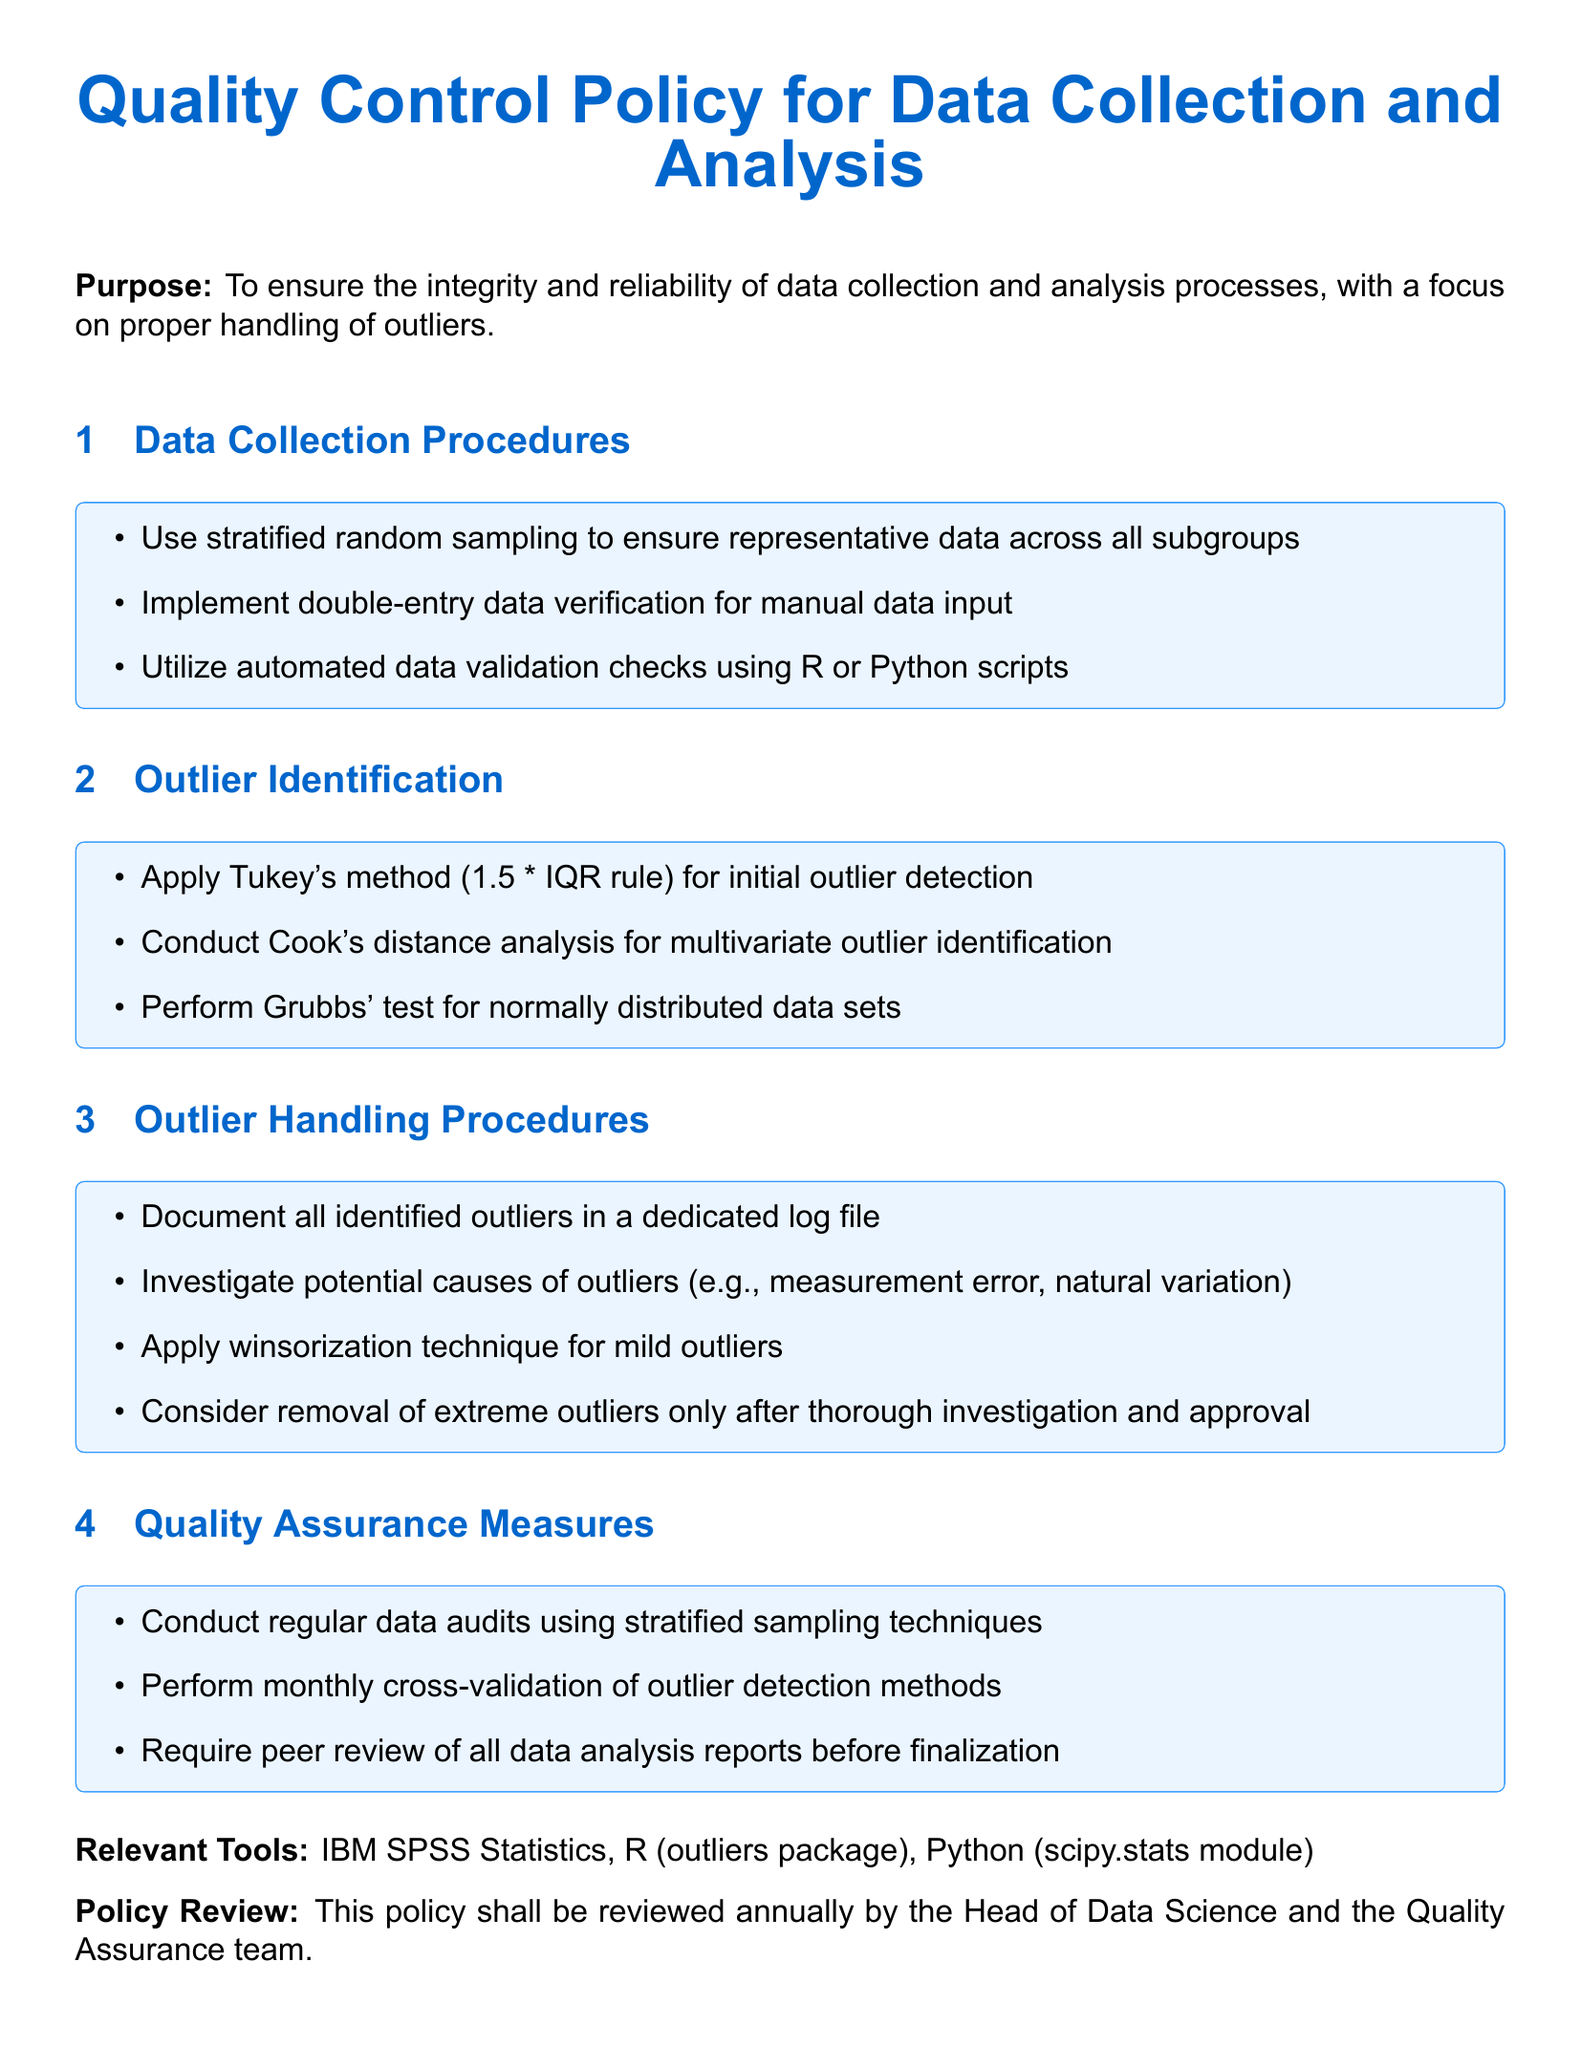What is the purpose of the policy? The purpose outlines the primary goal of the document, which is to ensure data integrity and reliability with a focus on outliers.
Answer: To ensure the integrity and reliability of data collection and analysis processes, with a focus on proper handling of outliers What sampling method is recommended for data collection? This refers to the sampling technique mentioned in the procedures for data collection within the document.
Answer: Stratified random sampling Which tool is mentioned for outlier detection? This identifies a specific tool indicated in the document for analyzing outliers in data.
Answer: R (outliers package) What is the method used for initial outlier detection? This relates to the specified technique for detecting outliers as detailed under the outlier identification section.
Answer: Tukey's method (1.5 * IQR rule) What should be included in the dedicated log file? This question pertains to what needs to be documented as part of outlier handling procedures.
Answer: All identified outliers Who is responsible for reviewing the policy? This identifies the individual or role tasked with the review of the policy document annually.
Answer: Head of Data Science How often should data audits be conducted? This reflects the frequency mentioned in the quality assurance measures section for conducting audits.
Answer: Regularly What analysis is performed for multivariate outlier identification? This refers to the type of analysis that is specifically recommended for identifying multivariate outliers.
Answer: Cook's distance analysis 